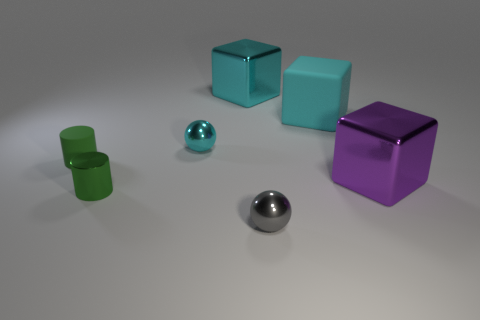What is the shape of the cyan metallic thing that is the same size as the purple cube?
Your answer should be very brief. Cube. Are there any other things that have the same size as the green metal cylinder?
Ensure brevity in your answer.  Yes. There is a cyan object left of the metal object that is behind the big matte block; what is it made of?
Give a very brief answer. Metal. Do the gray metal object and the purple metal object have the same size?
Keep it short and to the point. No. How many objects are small shiny things that are left of the tiny gray metal thing or metal blocks?
Your answer should be compact. 4. What is the shape of the big metal thing that is on the right side of the large block behind the cyan rubber thing?
Your answer should be compact. Cube. Is the size of the cyan shiny sphere the same as the ball in front of the large purple cube?
Your response must be concise. Yes. What is the small cylinder that is to the right of the matte cylinder made of?
Keep it short and to the point. Metal. How many things are both in front of the cyan ball and behind the large purple block?
Your answer should be very brief. 1. There is a purple object that is the same size as the cyan rubber cube; what is it made of?
Provide a short and direct response. Metal. 